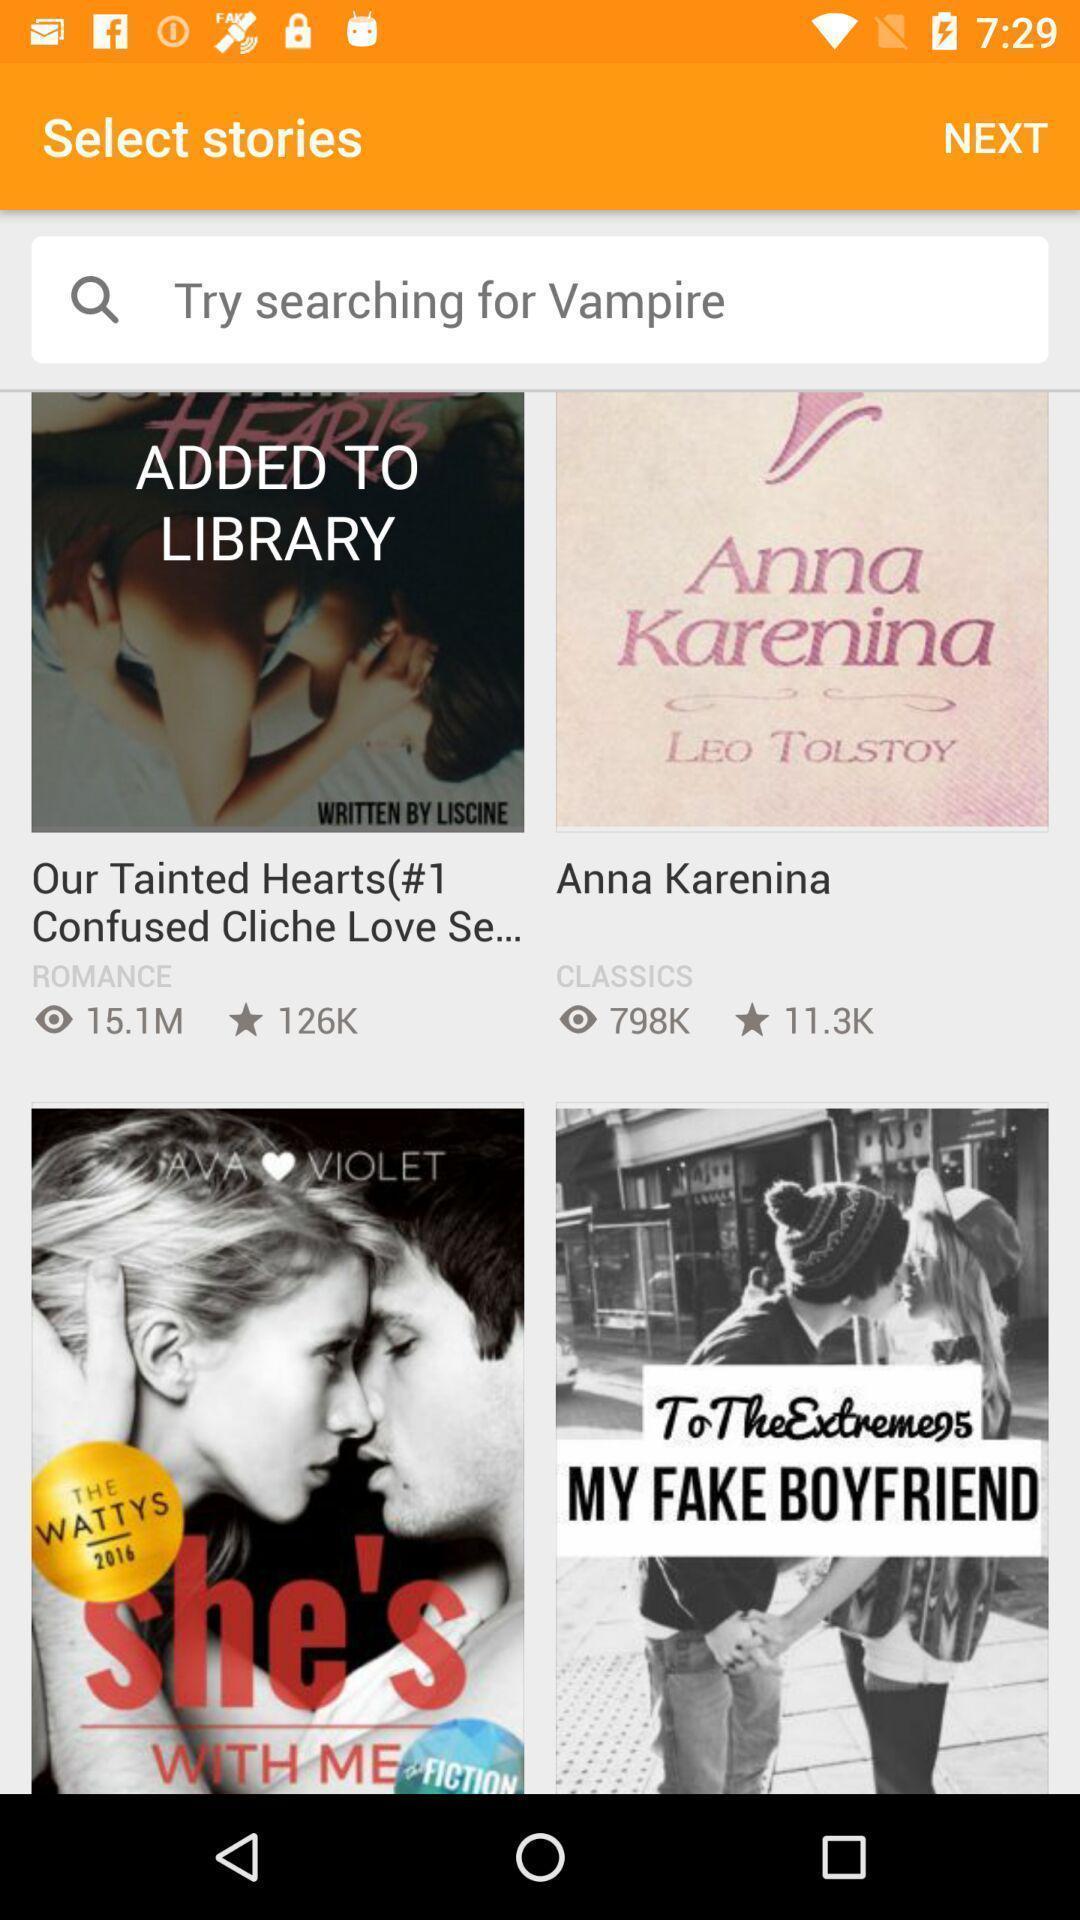Tell me about the visual elements in this screen capture. Screen displaying a search bar for different stories. 